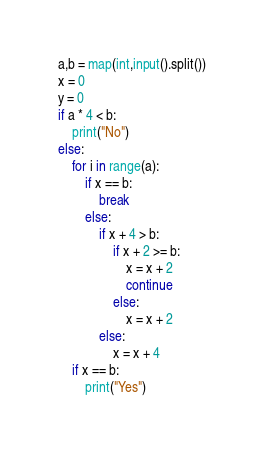<code> <loc_0><loc_0><loc_500><loc_500><_Python_>a,b = map(int,input().split())
x = 0
y = 0
if a * 4 < b:
    print("No")
else:
    for i in range(a):
        if x == b:
            break
        else:
            if x + 4 > b:
                if x + 2 >= b:
                    x = x + 2
                    continue
                else:
                    x = x + 2
            else:
                x = x + 4
    if x == b:
        print("Yes")</code> 